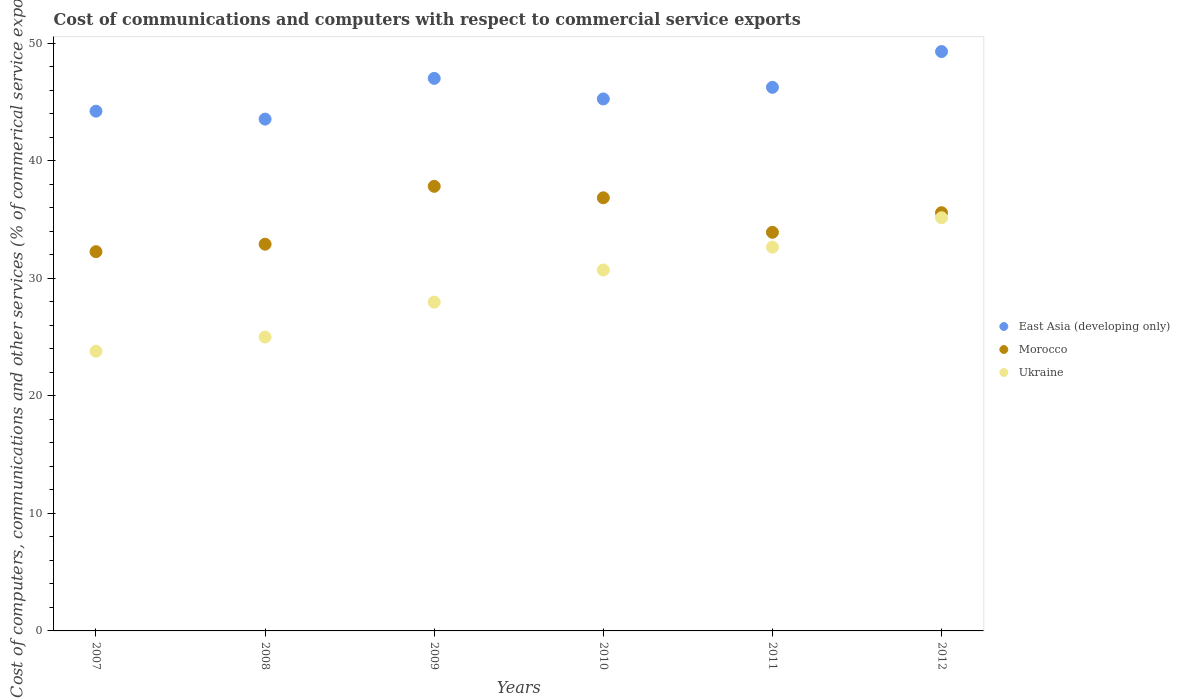Is the number of dotlines equal to the number of legend labels?
Your answer should be very brief. Yes. What is the cost of communications and computers in Ukraine in 2011?
Your answer should be very brief. 32.64. Across all years, what is the maximum cost of communications and computers in Ukraine?
Your answer should be very brief. 35.14. Across all years, what is the minimum cost of communications and computers in East Asia (developing only)?
Ensure brevity in your answer.  43.53. In which year was the cost of communications and computers in Morocco maximum?
Make the answer very short. 2009. In which year was the cost of communications and computers in Ukraine minimum?
Offer a very short reply. 2007. What is the total cost of communications and computers in Ukraine in the graph?
Your answer should be compact. 175.23. What is the difference between the cost of communications and computers in Ukraine in 2007 and that in 2009?
Your answer should be very brief. -4.18. What is the difference between the cost of communications and computers in East Asia (developing only) in 2011 and the cost of communications and computers in Morocco in 2012?
Give a very brief answer. 10.66. What is the average cost of communications and computers in East Asia (developing only) per year?
Provide a succinct answer. 45.92. In the year 2009, what is the difference between the cost of communications and computers in East Asia (developing only) and cost of communications and computers in Morocco?
Provide a succinct answer. 9.18. What is the ratio of the cost of communications and computers in Ukraine in 2007 to that in 2011?
Provide a succinct answer. 0.73. Is the cost of communications and computers in Morocco in 2007 less than that in 2010?
Make the answer very short. Yes. Is the difference between the cost of communications and computers in East Asia (developing only) in 2008 and 2012 greater than the difference between the cost of communications and computers in Morocco in 2008 and 2012?
Provide a succinct answer. No. What is the difference between the highest and the second highest cost of communications and computers in Ukraine?
Offer a very short reply. 2.5. What is the difference between the highest and the lowest cost of communications and computers in East Asia (developing only)?
Your answer should be compact. 5.75. In how many years, is the cost of communications and computers in Morocco greater than the average cost of communications and computers in Morocco taken over all years?
Offer a very short reply. 3. Is it the case that in every year, the sum of the cost of communications and computers in Ukraine and cost of communications and computers in Morocco  is greater than the cost of communications and computers in East Asia (developing only)?
Keep it short and to the point. Yes. Is the cost of communications and computers in East Asia (developing only) strictly less than the cost of communications and computers in Ukraine over the years?
Your response must be concise. No. How many dotlines are there?
Your answer should be very brief. 3. Does the graph contain grids?
Offer a terse response. No. Where does the legend appear in the graph?
Your response must be concise. Center right. How many legend labels are there?
Give a very brief answer. 3. How are the legend labels stacked?
Give a very brief answer. Vertical. What is the title of the graph?
Give a very brief answer. Cost of communications and computers with respect to commercial service exports. Does "Rwanda" appear as one of the legend labels in the graph?
Keep it short and to the point. No. What is the label or title of the X-axis?
Your response must be concise. Years. What is the label or title of the Y-axis?
Provide a succinct answer. Cost of computers, communications and other services (% of commerical service exports). What is the Cost of computers, communications and other services (% of commerical service exports) of East Asia (developing only) in 2007?
Make the answer very short. 44.21. What is the Cost of computers, communications and other services (% of commerical service exports) in Morocco in 2007?
Your answer should be compact. 32.26. What is the Cost of computers, communications and other services (% of commerical service exports) in Ukraine in 2007?
Ensure brevity in your answer.  23.79. What is the Cost of computers, communications and other services (% of commerical service exports) in East Asia (developing only) in 2008?
Make the answer very short. 43.53. What is the Cost of computers, communications and other services (% of commerical service exports) in Morocco in 2008?
Offer a terse response. 32.89. What is the Cost of computers, communications and other services (% of commerical service exports) of Ukraine in 2008?
Offer a very short reply. 25. What is the Cost of computers, communications and other services (% of commerical service exports) of East Asia (developing only) in 2009?
Keep it short and to the point. 47. What is the Cost of computers, communications and other services (% of commerical service exports) of Morocco in 2009?
Keep it short and to the point. 37.81. What is the Cost of computers, communications and other services (% of commerical service exports) of Ukraine in 2009?
Provide a short and direct response. 27.96. What is the Cost of computers, communications and other services (% of commerical service exports) of East Asia (developing only) in 2010?
Provide a short and direct response. 45.25. What is the Cost of computers, communications and other services (% of commerical service exports) of Morocco in 2010?
Your answer should be compact. 36.84. What is the Cost of computers, communications and other services (% of commerical service exports) of Ukraine in 2010?
Offer a very short reply. 30.7. What is the Cost of computers, communications and other services (% of commerical service exports) in East Asia (developing only) in 2011?
Offer a terse response. 46.23. What is the Cost of computers, communications and other services (% of commerical service exports) in Morocco in 2011?
Offer a terse response. 33.9. What is the Cost of computers, communications and other services (% of commerical service exports) in Ukraine in 2011?
Offer a very short reply. 32.64. What is the Cost of computers, communications and other services (% of commerical service exports) in East Asia (developing only) in 2012?
Your response must be concise. 49.28. What is the Cost of computers, communications and other services (% of commerical service exports) in Morocco in 2012?
Provide a short and direct response. 35.57. What is the Cost of computers, communications and other services (% of commerical service exports) of Ukraine in 2012?
Give a very brief answer. 35.14. Across all years, what is the maximum Cost of computers, communications and other services (% of commerical service exports) of East Asia (developing only)?
Make the answer very short. 49.28. Across all years, what is the maximum Cost of computers, communications and other services (% of commerical service exports) in Morocco?
Keep it short and to the point. 37.81. Across all years, what is the maximum Cost of computers, communications and other services (% of commerical service exports) in Ukraine?
Provide a short and direct response. 35.14. Across all years, what is the minimum Cost of computers, communications and other services (% of commerical service exports) in East Asia (developing only)?
Give a very brief answer. 43.53. Across all years, what is the minimum Cost of computers, communications and other services (% of commerical service exports) of Morocco?
Offer a very short reply. 32.26. Across all years, what is the minimum Cost of computers, communications and other services (% of commerical service exports) in Ukraine?
Your answer should be compact. 23.79. What is the total Cost of computers, communications and other services (% of commerical service exports) of East Asia (developing only) in the graph?
Offer a very short reply. 275.49. What is the total Cost of computers, communications and other services (% of commerical service exports) of Morocco in the graph?
Provide a succinct answer. 209.27. What is the total Cost of computers, communications and other services (% of commerical service exports) of Ukraine in the graph?
Your answer should be compact. 175.23. What is the difference between the Cost of computers, communications and other services (% of commerical service exports) in East Asia (developing only) in 2007 and that in 2008?
Your response must be concise. 0.68. What is the difference between the Cost of computers, communications and other services (% of commerical service exports) of Morocco in 2007 and that in 2008?
Your response must be concise. -0.64. What is the difference between the Cost of computers, communications and other services (% of commerical service exports) of Ukraine in 2007 and that in 2008?
Your answer should be very brief. -1.21. What is the difference between the Cost of computers, communications and other services (% of commerical service exports) of East Asia (developing only) in 2007 and that in 2009?
Your answer should be compact. -2.79. What is the difference between the Cost of computers, communications and other services (% of commerical service exports) of Morocco in 2007 and that in 2009?
Offer a very short reply. -5.56. What is the difference between the Cost of computers, communications and other services (% of commerical service exports) in Ukraine in 2007 and that in 2009?
Provide a short and direct response. -4.18. What is the difference between the Cost of computers, communications and other services (% of commerical service exports) in East Asia (developing only) in 2007 and that in 2010?
Offer a very short reply. -1.04. What is the difference between the Cost of computers, communications and other services (% of commerical service exports) in Morocco in 2007 and that in 2010?
Your answer should be compact. -4.58. What is the difference between the Cost of computers, communications and other services (% of commerical service exports) of Ukraine in 2007 and that in 2010?
Your response must be concise. -6.91. What is the difference between the Cost of computers, communications and other services (% of commerical service exports) of East Asia (developing only) in 2007 and that in 2011?
Your answer should be compact. -2.03. What is the difference between the Cost of computers, communications and other services (% of commerical service exports) in Morocco in 2007 and that in 2011?
Offer a very short reply. -1.65. What is the difference between the Cost of computers, communications and other services (% of commerical service exports) of Ukraine in 2007 and that in 2011?
Provide a succinct answer. -8.85. What is the difference between the Cost of computers, communications and other services (% of commerical service exports) in East Asia (developing only) in 2007 and that in 2012?
Provide a succinct answer. -5.07. What is the difference between the Cost of computers, communications and other services (% of commerical service exports) in Morocco in 2007 and that in 2012?
Offer a very short reply. -3.31. What is the difference between the Cost of computers, communications and other services (% of commerical service exports) of Ukraine in 2007 and that in 2012?
Offer a terse response. -11.35. What is the difference between the Cost of computers, communications and other services (% of commerical service exports) in East Asia (developing only) in 2008 and that in 2009?
Keep it short and to the point. -3.46. What is the difference between the Cost of computers, communications and other services (% of commerical service exports) in Morocco in 2008 and that in 2009?
Keep it short and to the point. -4.92. What is the difference between the Cost of computers, communications and other services (% of commerical service exports) of Ukraine in 2008 and that in 2009?
Your response must be concise. -2.97. What is the difference between the Cost of computers, communications and other services (% of commerical service exports) in East Asia (developing only) in 2008 and that in 2010?
Provide a short and direct response. -1.72. What is the difference between the Cost of computers, communications and other services (% of commerical service exports) in Morocco in 2008 and that in 2010?
Offer a very short reply. -3.95. What is the difference between the Cost of computers, communications and other services (% of commerical service exports) of Ukraine in 2008 and that in 2010?
Provide a short and direct response. -5.71. What is the difference between the Cost of computers, communications and other services (% of commerical service exports) in East Asia (developing only) in 2008 and that in 2011?
Make the answer very short. -2.7. What is the difference between the Cost of computers, communications and other services (% of commerical service exports) of Morocco in 2008 and that in 2011?
Your response must be concise. -1.01. What is the difference between the Cost of computers, communications and other services (% of commerical service exports) of Ukraine in 2008 and that in 2011?
Your answer should be very brief. -7.65. What is the difference between the Cost of computers, communications and other services (% of commerical service exports) in East Asia (developing only) in 2008 and that in 2012?
Your answer should be very brief. -5.75. What is the difference between the Cost of computers, communications and other services (% of commerical service exports) of Morocco in 2008 and that in 2012?
Your response must be concise. -2.68. What is the difference between the Cost of computers, communications and other services (% of commerical service exports) in Ukraine in 2008 and that in 2012?
Your response must be concise. -10.15. What is the difference between the Cost of computers, communications and other services (% of commerical service exports) of East Asia (developing only) in 2009 and that in 2010?
Offer a terse response. 1.75. What is the difference between the Cost of computers, communications and other services (% of commerical service exports) in Morocco in 2009 and that in 2010?
Offer a terse response. 0.98. What is the difference between the Cost of computers, communications and other services (% of commerical service exports) of Ukraine in 2009 and that in 2010?
Your response must be concise. -2.74. What is the difference between the Cost of computers, communications and other services (% of commerical service exports) in East Asia (developing only) in 2009 and that in 2011?
Make the answer very short. 0.76. What is the difference between the Cost of computers, communications and other services (% of commerical service exports) of Morocco in 2009 and that in 2011?
Your answer should be compact. 3.91. What is the difference between the Cost of computers, communications and other services (% of commerical service exports) of Ukraine in 2009 and that in 2011?
Provide a succinct answer. -4.68. What is the difference between the Cost of computers, communications and other services (% of commerical service exports) of East Asia (developing only) in 2009 and that in 2012?
Offer a very short reply. -2.28. What is the difference between the Cost of computers, communications and other services (% of commerical service exports) of Morocco in 2009 and that in 2012?
Ensure brevity in your answer.  2.24. What is the difference between the Cost of computers, communications and other services (% of commerical service exports) of Ukraine in 2009 and that in 2012?
Offer a very short reply. -7.18. What is the difference between the Cost of computers, communications and other services (% of commerical service exports) of East Asia (developing only) in 2010 and that in 2011?
Give a very brief answer. -0.99. What is the difference between the Cost of computers, communications and other services (% of commerical service exports) of Morocco in 2010 and that in 2011?
Give a very brief answer. 2.93. What is the difference between the Cost of computers, communications and other services (% of commerical service exports) in Ukraine in 2010 and that in 2011?
Your answer should be compact. -1.94. What is the difference between the Cost of computers, communications and other services (% of commerical service exports) in East Asia (developing only) in 2010 and that in 2012?
Provide a succinct answer. -4.03. What is the difference between the Cost of computers, communications and other services (% of commerical service exports) in Morocco in 2010 and that in 2012?
Your answer should be compact. 1.27. What is the difference between the Cost of computers, communications and other services (% of commerical service exports) in Ukraine in 2010 and that in 2012?
Keep it short and to the point. -4.44. What is the difference between the Cost of computers, communications and other services (% of commerical service exports) in East Asia (developing only) in 2011 and that in 2012?
Your response must be concise. -3.04. What is the difference between the Cost of computers, communications and other services (% of commerical service exports) of Morocco in 2011 and that in 2012?
Provide a short and direct response. -1.67. What is the difference between the Cost of computers, communications and other services (% of commerical service exports) of Ukraine in 2011 and that in 2012?
Offer a very short reply. -2.5. What is the difference between the Cost of computers, communications and other services (% of commerical service exports) of East Asia (developing only) in 2007 and the Cost of computers, communications and other services (% of commerical service exports) of Morocco in 2008?
Give a very brief answer. 11.31. What is the difference between the Cost of computers, communications and other services (% of commerical service exports) in East Asia (developing only) in 2007 and the Cost of computers, communications and other services (% of commerical service exports) in Ukraine in 2008?
Provide a succinct answer. 19.21. What is the difference between the Cost of computers, communications and other services (% of commerical service exports) in Morocco in 2007 and the Cost of computers, communications and other services (% of commerical service exports) in Ukraine in 2008?
Your answer should be compact. 7.26. What is the difference between the Cost of computers, communications and other services (% of commerical service exports) of East Asia (developing only) in 2007 and the Cost of computers, communications and other services (% of commerical service exports) of Morocco in 2009?
Ensure brevity in your answer.  6.39. What is the difference between the Cost of computers, communications and other services (% of commerical service exports) of East Asia (developing only) in 2007 and the Cost of computers, communications and other services (% of commerical service exports) of Ukraine in 2009?
Keep it short and to the point. 16.24. What is the difference between the Cost of computers, communications and other services (% of commerical service exports) of Morocco in 2007 and the Cost of computers, communications and other services (% of commerical service exports) of Ukraine in 2009?
Keep it short and to the point. 4.29. What is the difference between the Cost of computers, communications and other services (% of commerical service exports) in East Asia (developing only) in 2007 and the Cost of computers, communications and other services (% of commerical service exports) in Morocco in 2010?
Ensure brevity in your answer.  7.37. What is the difference between the Cost of computers, communications and other services (% of commerical service exports) in East Asia (developing only) in 2007 and the Cost of computers, communications and other services (% of commerical service exports) in Ukraine in 2010?
Ensure brevity in your answer.  13.5. What is the difference between the Cost of computers, communications and other services (% of commerical service exports) of Morocco in 2007 and the Cost of computers, communications and other services (% of commerical service exports) of Ukraine in 2010?
Keep it short and to the point. 1.55. What is the difference between the Cost of computers, communications and other services (% of commerical service exports) in East Asia (developing only) in 2007 and the Cost of computers, communications and other services (% of commerical service exports) in Morocco in 2011?
Ensure brevity in your answer.  10.3. What is the difference between the Cost of computers, communications and other services (% of commerical service exports) in East Asia (developing only) in 2007 and the Cost of computers, communications and other services (% of commerical service exports) in Ukraine in 2011?
Give a very brief answer. 11.56. What is the difference between the Cost of computers, communications and other services (% of commerical service exports) of Morocco in 2007 and the Cost of computers, communications and other services (% of commerical service exports) of Ukraine in 2011?
Your response must be concise. -0.39. What is the difference between the Cost of computers, communications and other services (% of commerical service exports) of East Asia (developing only) in 2007 and the Cost of computers, communications and other services (% of commerical service exports) of Morocco in 2012?
Your answer should be very brief. 8.63. What is the difference between the Cost of computers, communications and other services (% of commerical service exports) of East Asia (developing only) in 2007 and the Cost of computers, communications and other services (% of commerical service exports) of Ukraine in 2012?
Provide a succinct answer. 9.06. What is the difference between the Cost of computers, communications and other services (% of commerical service exports) of Morocco in 2007 and the Cost of computers, communications and other services (% of commerical service exports) of Ukraine in 2012?
Make the answer very short. -2.89. What is the difference between the Cost of computers, communications and other services (% of commerical service exports) in East Asia (developing only) in 2008 and the Cost of computers, communications and other services (% of commerical service exports) in Morocco in 2009?
Ensure brevity in your answer.  5.72. What is the difference between the Cost of computers, communications and other services (% of commerical service exports) of East Asia (developing only) in 2008 and the Cost of computers, communications and other services (% of commerical service exports) of Ukraine in 2009?
Offer a very short reply. 15.57. What is the difference between the Cost of computers, communications and other services (% of commerical service exports) in Morocco in 2008 and the Cost of computers, communications and other services (% of commerical service exports) in Ukraine in 2009?
Make the answer very short. 4.93. What is the difference between the Cost of computers, communications and other services (% of commerical service exports) in East Asia (developing only) in 2008 and the Cost of computers, communications and other services (% of commerical service exports) in Morocco in 2010?
Your response must be concise. 6.69. What is the difference between the Cost of computers, communications and other services (% of commerical service exports) of East Asia (developing only) in 2008 and the Cost of computers, communications and other services (% of commerical service exports) of Ukraine in 2010?
Give a very brief answer. 12.83. What is the difference between the Cost of computers, communications and other services (% of commerical service exports) of Morocco in 2008 and the Cost of computers, communications and other services (% of commerical service exports) of Ukraine in 2010?
Ensure brevity in your answer.  2.19. What is the difference between the Cost of computers, communications and other services (% of commerical service exports) in East Asia (developing only) in 2008 and the Cost of computers, communications and other services (% of commerical service exports) in Morocco in 2011?
Your answer should be compact. 9.63. What is the difference between the Cost of computers, communications and other services (% of commerical service exports) in East Asia (developing only) in 2008 and the Cost of computers, communications and other services (% of commerical service exports) in Ukraine in 2011?
Your answer should be compact. 10.89. What is the difference between the Cost of computers, communications and other services (% of commerical service exports) of Morocco in 2008 and the Cost of computers, communications and other services (% of commerical service exports) of Ukraine in 2011?
Give a very brief answer. 0.25. What is the difference between the Cost of computers, communications and other services (% of commerical service exports) of East Asia (developing only) in 2008 and the Cost of computers, communications and other services (% of commerical service exports) of Morocco in 2012?
Make the answer very short. 7.96. What is the difference between the Cost of computers, communications and other services (% of commerical service exports) of East Asia (developing only) in 2008 and the Cost of computers, communications and other services (% of commerical service exports) of Ukraine in 2012?
Offer a terse response. 8.39. What is the difference between the Cost of computers, communications and other services (% of commerical service exports) in Morocco in 2008 and the Cost of computers, communications and other services (% of commerical service exports) in Ukraine in 2012?
Make the answer very short. -2.25. What is the difference between the Cost of computers, communications and other services (% of commerical service exports) of East Asia (developing only) in 2009 and the Cost of computers, communications and other services (% of commerical service exports) of Morocco in 2010?
Provide a short and direct response. 10.16. What is the difference between the Cost of computers, communications and other services (% of commerical service exports) in East Asia (developing only) in 2009 and the Cost of computers, communications and other services (% of commerical service exports) in Ukraine in 2010?
Your answer should be very brief. 16.29. What is the difference between the Cost of computers, communications and other services (% of commerical service exports) of Morocco in 2009 and the Cost of computers, communications and other services (% of commerical service exports) of Ukraine in 2010?
Your answer should be very brief. 7.11. What is the difference between the Cost of computers, communications and other services (% of commerical service exports) of East Asia (developing only) in 2009 and the Cost of computers, communications and other services (% of commerical service exports) of Morocco in 2011?
Provide a short and direct response. 13.09. What is the difference between the Cost of computers, communications and other services (% of commerical service exports) of East Asia (developing only) in 2009 and the Cost of computers, communications and other services (% of commerical service exports) of Ukraine in 2011?
Offer a terse response. 14.35. What is the difference between the Cost of computers, communications and other services (% of commerical service exports) in Morocco in 2009 and the Cost of computers, communications and other services (% of commerical service exports) in Ukraine in 2011?
Make the answer very short. 5.17. What is the difference between the Cost of computers, communications and other services (% of commerical service exports) in East Asia (developing only) in 2009 and the Cost of computers, communications and other services (% of commerical service exports) in Morocco in 2012?
Offer a terse response. 11.43. What is the difference between the Cost of computers, communications and other services (% of commerical service exports) of East Asia (developing only) in 2009 and the Cost of computers, communications and other services (% of commerical service exports) of Ukraine in 2012?
Offer a terse response. 11.85. What is the difference between the Cost of computers, communications and other services (% of commerical service exports) in Morocco in 2009 and the Cost of computers, communications and other services (% of commerical service exports) in Ukraine in 2012?
Provide a succinct answer. 2.67. What is the difference between the Cost of computers, communications and other services (% of commerical service exports) in East Asia (developing only) in 2010 and the Cost of computers, communications and other services (% of commerical service exports) in Morocco in 2011?
Keep it short and to the point. 11.34. What is the difference between the Cost of computers, communications and other services (% of commerical service exports) in East Asia (developing only) in 2010 and the Cost of computers, communications and other services (% of commerical service exports) in Ukraine in 2011?
Offer a terse response. 12.61. What is the difference between the Cost of computers, communications and other services (% of commerical service exports) in Morocco in 2010 and the Cost of computers, communications and other services (% of commerical service exports) in Ukraine in 2011?
Your response must be concise. 4.2. What is the difference between the Cost of computers, communications and other services (% of commerical service exports) of East Asia (developing only) in 2010 and the Cost of computers, communications and other services (% of commerical service exports) of Morocco in 2012?
Your answer should be compact. 9.68. What is the difference between the Cost of computers, communications and other services (% of commerical service exports) in East Asia (developing only) in 2010 and the Cost of computers, communications and other services (% of commerical service exports) in Ukraine in 2012?
Ensure brevity in your answer.  10.1. What is the difference between the Cost of computers, communications and other services (% of commerical service exports) in Morocco in 2010 and the Cost of computers, communications and other services (% of commerical service exports) in Ukraine in 2012?
Give a very brief answer. 1.7. What is the difference between the Cost of computers, communications and other services (% of commerical service exports) in East Asia (developing only) in 2011 and the Cost of computers, communications and other services (% of commerical service exports) in Morocco in 2012?
Ensure brevity in your answer.  10.66. What is the difference between the Cost of computers, communications and other services (% of commerical service exports) in East Asia (developing only) in 2011 and the Cost of computers, communications and other services (% of commerical service exports) in Ukraine in 2012?
Provide a short and direct response. 11.09. What is the difference between the Cost of computers, communications and other services (% of commerical service exports) of Morocco in 2011 and the Cost of computers, communications and other services (% of commerical service exports) of Ukraine in 2012?
Provide a succinct answer. -1.24. What is the average Cost of computers, communications and other services (% of commerical service exports) of East Asia (developing only) per year?
Make the answer very short. 45.91. What is the average Cost of computers, communications and other services (% of commerical service exports) of Morocco per year?
Give a very brief answer. 34.88. What is the average Cost of computers, communications and other services (% of commerical service exports) of Ukraine per year?
Make the answer very short. 29.21. In the year 2007, what is the difference between the Cost of computers, communications and other services (% of commerical service exports) of East Asia (developing only) and Cost of computers, communications and other services (% of commerical service exports) of Morocco?
Keep it short and to the point. 11.95. In the year 2007, what is the difference between the Cost of computers, communications and other services (% of commerical service exports) of East Asia (developing only) and Cost of computers, communications and other services (% of commerical service exports) of Ukraine?
Give a very brief answer. 20.42. In the year 2007, what is the difference between the Cost of computers, communications and other services (% of commerical service exports) in Morocco and Cost of computers, communications and other services (% of commerical service exports) in Ukraine?
Ensure brevity in your answer.  8.47. In the year 2008, what is the difference between the Cost of computers, communications and other services (% of commerical service exports) of East Asia (developing only) and Cost of computers, communications and other services (% of commerical service exports) of Morocco?
Ensure brevity in your answer.  10.64. In the year 2008, what is the difference between the Cost of computers, communications and other services (% of commerical service exports) of East Asia (developing only) and Cost of computers, communications and other services (% of commerical service exports) of Ukraine?
Give a very brief answer. 18.53. In the year 2008, what is the difference between the Cost of computers, communications and other services (% of commerical service exports) of Morocco and Cost of computers, communications and other services (% of commerical service exports) of Ukraine?
Ensure brevity in your answer.  7.9. In the year 2009, what is the difference between the Cost of computers, communications and other services (% of commerical service exports) in East Asia (developing only) and Cost of computers, communications and other services (% of commerical service exports) in Morocco?
Your answer should be very brief. 9.18. In the year 2009, what is the difference between the Cost of computers, communications and other services (% of commerical service exports) in East Asia (developing only) and Cost of computers, communications and other services (% of commerical service exports) in Ukraine?
Keep it short and to the point. 19.03. In the year 2009, what is the difference between the Cost of computers, communications and other services (% of commerical service exports) in Morocco and Cost of computers, communications and other services (% of commerical service exports) in Ukraine?
Make the answer very short. 9.85. In the year 2010, what is the difference between the Cost of computers, communications and other services (% of commerical service exports) of East Asia (developing only) and Cost of computers, communications and other services (% of commerical service exports) of Morocco?
Your response must be concise. 8.41. In the year 2010, what is the difference between the Cost of computers, communications and other services (% of commerical service exports) in East Asia (developing only) and Cost of computers, communications and other services (% of commerical service exports) in Ukraine?
Provide a succinct answer. 14.55. In the year 2010, what is the difference between the Cost of computers, communications and other services (% of commerical service exports) in Morocco and Cost of computers, communications and other services (% of commerical service exports) in Ukraine?
Make the answer very short. 6.14. In the year 2011, what is the difference between the Cost of computers, communications and other services (% of commerical service exports) of East Asia (developing only) and Cost of computers, communications and other services (% of commerical service exports) of Morocco?
Make the answer very short. 12.33. In the year 2011, what is the difference between the Cost of computers, communications and other services (% of commerical service exports) of East Asia (developing only) and Cost of computers, communications and other services (% of commerical service exports) of Ukraine?
Offer a very short reply. 13.59. In the year 2011, what is the difference between the Cost of computers, communications and other services (% of commerical service exports) in Morocco and Cost of computers, communications and other services (% of commerical service exports) in Ukraine?
Your response must be concise. 1.26. In the year 2012, what is the difference between the Cost of computers, communications and other services (% of commerical service exports) in East Asia (developing only) and Cost of computers, communications and other services (% of commerical service exports) in Morocco?
Give a very brief answer. 13.71. In the year 2012, what is the difference between the Cost of computers, communications and other services (% of commerical service exports) in East Asia (developing only) and Cost of computers, communications and other services (% of commerical service exports) in Ukraine?
Ensure brevity in your answer.  14.13. In the year 2012, what is the difference between the Cost of computers, communications and other services (% of commerical service exports) in Morocco and Cost of computers, communications and other services (% of commerical service exports) in Ukraine?
Make the answer very short. 0.43. What is the ratio of the Cost of computers, communications and other services (% of commerical service exports) in East Asia (developing only) in 2007 to that in 2008?
Offer a very short reply. 1.02. What is the ratio of the Cost of computers, communications and other services (% of commerical service exports) of Morocco in 2007 to that in 2008?
Your answer should be compact. 0.98. What is the ratio of the Cost of computers, communications and other services (% of commerical service exports) of Ukraine in 2007 to that in 2008?
Make the answer very short. 0.95. What is the ratio of the Cost of computers, communications and other services (% of commerical service exports) in East Asia (developing only) in 2007 to that in 2009?
Give a very brief answer. 0.94. What is the ratio of the Cost of computers, communications and other services (% of commerical service exports) in Morocco in 2007 to that in 2009?
Keep it short and to the point. 0.85. What is the ratio of the Cost of computers, communications and other services (% of commerical service exports) in Ukraine in 2007 to that in 2009?
Provide a short and direct response. 0.85. What is the ratio of the Cost of computers, communications and other services (% of commerical service exports) in East Asia (developing only) in 2007 to that in 2010?
Make the answer very short. 0.98. What is the ratio of the Cost of computers, communications and other services (% of commerical service exports) of Morocco in 2007 to that in 2010?
Make the answer very short. 0.88. What is the ratio of the Cost of computers, communications and other services (% of commerical service exports) of Ukraine in 2007 to that in 2010?
Offer a terse response. 0.77. What is the ratio of the Cost of computers, communications and other services (% of commerical service exports) of East Asia (developing only) in 2007 to that in 2011?
Ensure brevity in your answer.  0.96. What is the ratio of the Cost of computers, communications and other services (% of commerical service exports) of Morocco in 2007 to that in 2011?
Your answer should be very brief. 0.95. What is the ratio of the Cost of computers, communications and other services (% of commerical service exports) in Ukraine in 2007 to that in 2011?
Your answer should be compact. 0.73. What is the ratio of the Cost of computers, communications and other services (% of commerical service exports) in East Asia (developing only) in 2007 to that in 2012?
Ensure brevity in your answer.  0.9. What is the ratio of the Cost of computers, communications and other services (% of commerical service exports) in Morocco in 2007 to that in 2012?
Offer a very short reply. 0.91. What is the ratio of the Cost of computers, communications and other services (% of commerical service exports) of Ukraine in 2007 to that in 2012?
Make the answer very short. 0.68. What is the ratio of the Cost of computers, communications and other services (% of commerical service exports) in East Asia (developing only) in 2008 to that in 2009?
Your answer should be compact. 0.93. What is the ratio of the Cost of computers, communications and other services (% of commerical service exports) of Morocco in 2008 to that in 2009?
Provide a short and direct response. 0.87. What is the ratio of the Cost of computers, communications and other services (% of commerical service exports) of Ukraine in 2008 to that in 2009?
Your answer should be compact. 0.89. What is the ratio of the Cost of computers, communications and other services (% of commerical service exports) in East Asia (developing only) in 2008 to that in 2010?
Your response must be concise. 0.96. What is the ratio of the Cost of computers, communications and other services (% of commerical service exports) in Morocco in 2008 to that in 2010?
Provide a short and direct response. 0.89. What is the ratio of the Cost of computers, communications and other services (% of commerical service exports) in Ukraine in 2008 to that in 2010?
Keep it short and to the point. 0.81. What is the ratio of the Cost of computers, communications and other services (% of commerical service exports) of East Asia (developing only) in 2008 to that in 2011?
Your answer should be compact. 0.94. What is the ratio of the Cost of computers, communications and other services (% of commerical service exports) of Morocco in 2008 to that in 2011?
Keep it short and to the point. 0.97. What is the ratio of the Cost of computers, communications and other services (% of commerical service exports) of Ukraine in 2008 to that in 2011?
Ensure brevity in your answer.  0.77. What is the ratio of the Cost of computers, communications and other services (% of commerical service exports) in East Asia (developing only) in 2008 to that in 2012?
Your answer should be very brief. 0.88. What is the ratio of the Cost of computers, communications and other services (% of commerical service exports) of Morocco in 2008 to that in 2012?
Offer a very short reply. 0.92. What is the ratio of the Cost of computers, communications and other services (% of commerical service exports) in Ukraine in 2008 to that in 2012?
Make the answer very short. 0.71. What is the ratio of the Cost of computers, communications and other services (% of commerical service exports) of East Asia (developing only) in 2009 to that in 2010?
Keep it short and to the point. 1.04. What is the ratio of the Cost of computers, communications and other services (% of commerical service exports) of Morocco in 2009 to that in 2010?
Make the answer very short. 1.03. What is the ratio of the Cost of computers, communications and other services (% of commerical service exports) in Ukraine in 2009 to that in 2010?
Your answer should be very brief. 0.91. What is the ratio of the Cost of computers, communications and other services (% of commerical service exports) in East Asia (developing only) in 2009 to that in 2011?
Provide a succinct answer. 1.02. What is the ratio of the Cost of computers, communications and other services (% of commerical service exports) of Morocco in 2009 to that in 2011?
Offer a terse response. 1.12. What is the ratio of the Cost of computers, communications and other services (% of commerical service exports) in Ukraine in 2009 to that in 2011?
Keep it short and to the point. 0.86. What is the ratio of the Cost of computers, communications and other services (% of commerical service exports) in East Asia (developing only) in 2009 to that in 2012?
Keep it short and to the point. 0.95. What is the ratio of the Cost of computers, communications and other services (% of commerical service exports) in Morocco in 2009 to that in 2012?
Make the answer very short. 1.06. What is the ratio of the Cost of computers, communications and other services (% of commerical service exports) in Ukraine in 2009 to that in 2012?
Provide a short and direct response. 0.8. What is the ratio of the Cost of computers, communications and other services (% of commerical service exports) in East Asia (developing only) in 2010 to that in 2011?
Your response must be concise. 0.98. What is the ratio of the Cost of computers, communications and other services (% of commerical service exports) of Morocco in 2010 to that in 2011?
Give a very brief answer. 1.09. What is the ratio of the Cost of computers, communications and other services (% of commerical service exports) in Ukraine in 2010 to that in 2011?
Provide a short and direct response. 0.94. What is the ratio of the Cost of computers, communications and other services (% of commerical service exports) in East Asia (developing only) in 2010 to that in 2012?
Offer a terse response. 0.92. What is the ratio of the Cost of computers, communications and other services (% of commerical service exports) in Morocco in 2010 to that in 2012?
Make the answer very short. 1.04. What is the ratio of the Cost of computers, communications and other services (% of commerical service exports) in Ukraine in 2010 to that in 2012?
Provide a succinct answer. 0.87. What is the ratio of the Cost of computers, communications and other services (% of commerical service exports) in East Asia (developing only) in 2011 to that in 2012?
Give a very brief answer. 0.94. What is the ratio of the Cost of computers, communications and other services (% of commerical service exports) in Morocco in 2011 to that in 2012?
Your answer should be compact. 0.95. What is the ratio of the Cost of computers, communications and other services (% of commerical service exports) in Ukraine in 2011 to that in 2012?
Keep it short and to the point. 0.93. What is the difference between the highest and the second highest Cost of computers, communications and other services (% of commerical service exports) of East Asia (developing only)?
Make the answer very short. 2.28. What is the difference between the highest and the second highest Cost of computers, communications and other services (% of commerical service exports) in Ukraine?
Offer a terse response. 2.5. What is the difference between the highest and the lowest Cost of computers, communications and other services (% of commerical service exports) of East Asia (developing only)?
Provide a succinct answer. 5.75. What is the difference between the highest and the lowest Cost of computers, communications and other services (% of commerical service exports) of Morocco?
Your answer should be very brief. 5.56. What is the difference between the highest and the lowest Cost of computers, communications and other services (% of commerical service exports) of Ukraine?
Provide a succinct answer. 11.35. 